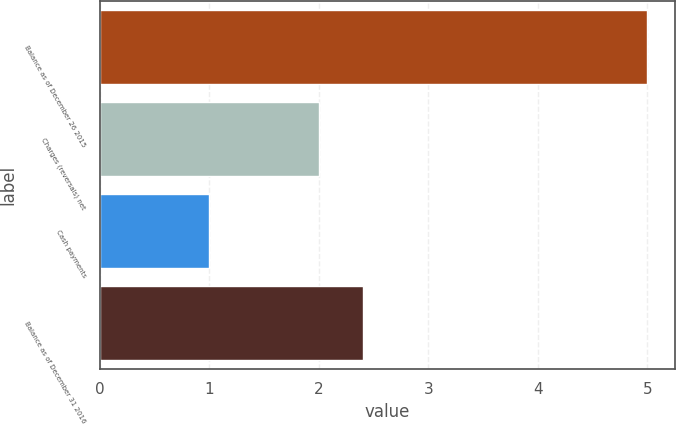Convert chart to OTSL. <chart><loc_0><loc_0><loc_500><loc_500><bar_chart><fcel>Balance as of December 26 2015<fcel>Charges (reversals) net<fcel>Cash payments<fcel>Balance as of December 31 2016<nl><fcel>5<fcel>2<fcel>1<fcel>2.4<nl></chart> 